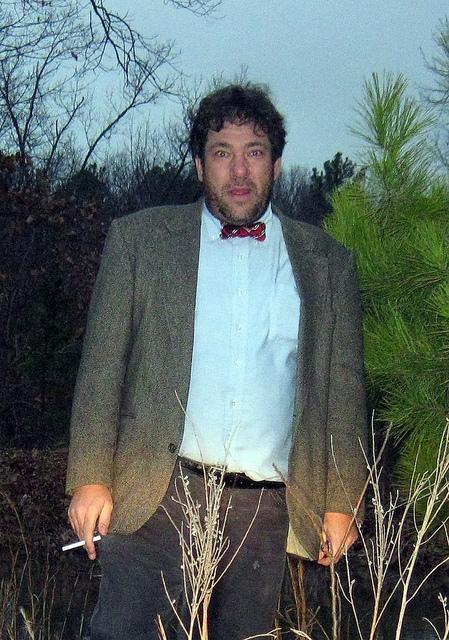How many people are there?
Give a very brief answer. 1. How many tracks have a train on them?
Give a very brief answer. 0. 